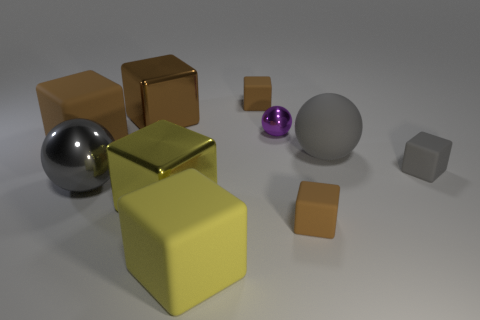Subtract all cyan balls. How many brown blocks are left? 4 Subtract 2 cubes. How many cubes are left? 5 Subtract all gray cubes. How many cubes are left? 6 Subtract all brown metal blocks. How many blocks are left? 6 Subtract all red spheres. Subtract all red cylinders. How many spheres are left? 3 Subtract all cubes. How many objects are left? 3 Subtract all large rubber spheres. Subtract all red cylinders. How many objects are left? 9 Add 9 brown shiny objects. How many brown shiny objects are left? 10 Add 2 metallic things. How many metallic things exist? 6 Subtract 0 red balls. How many objects are left? 10 